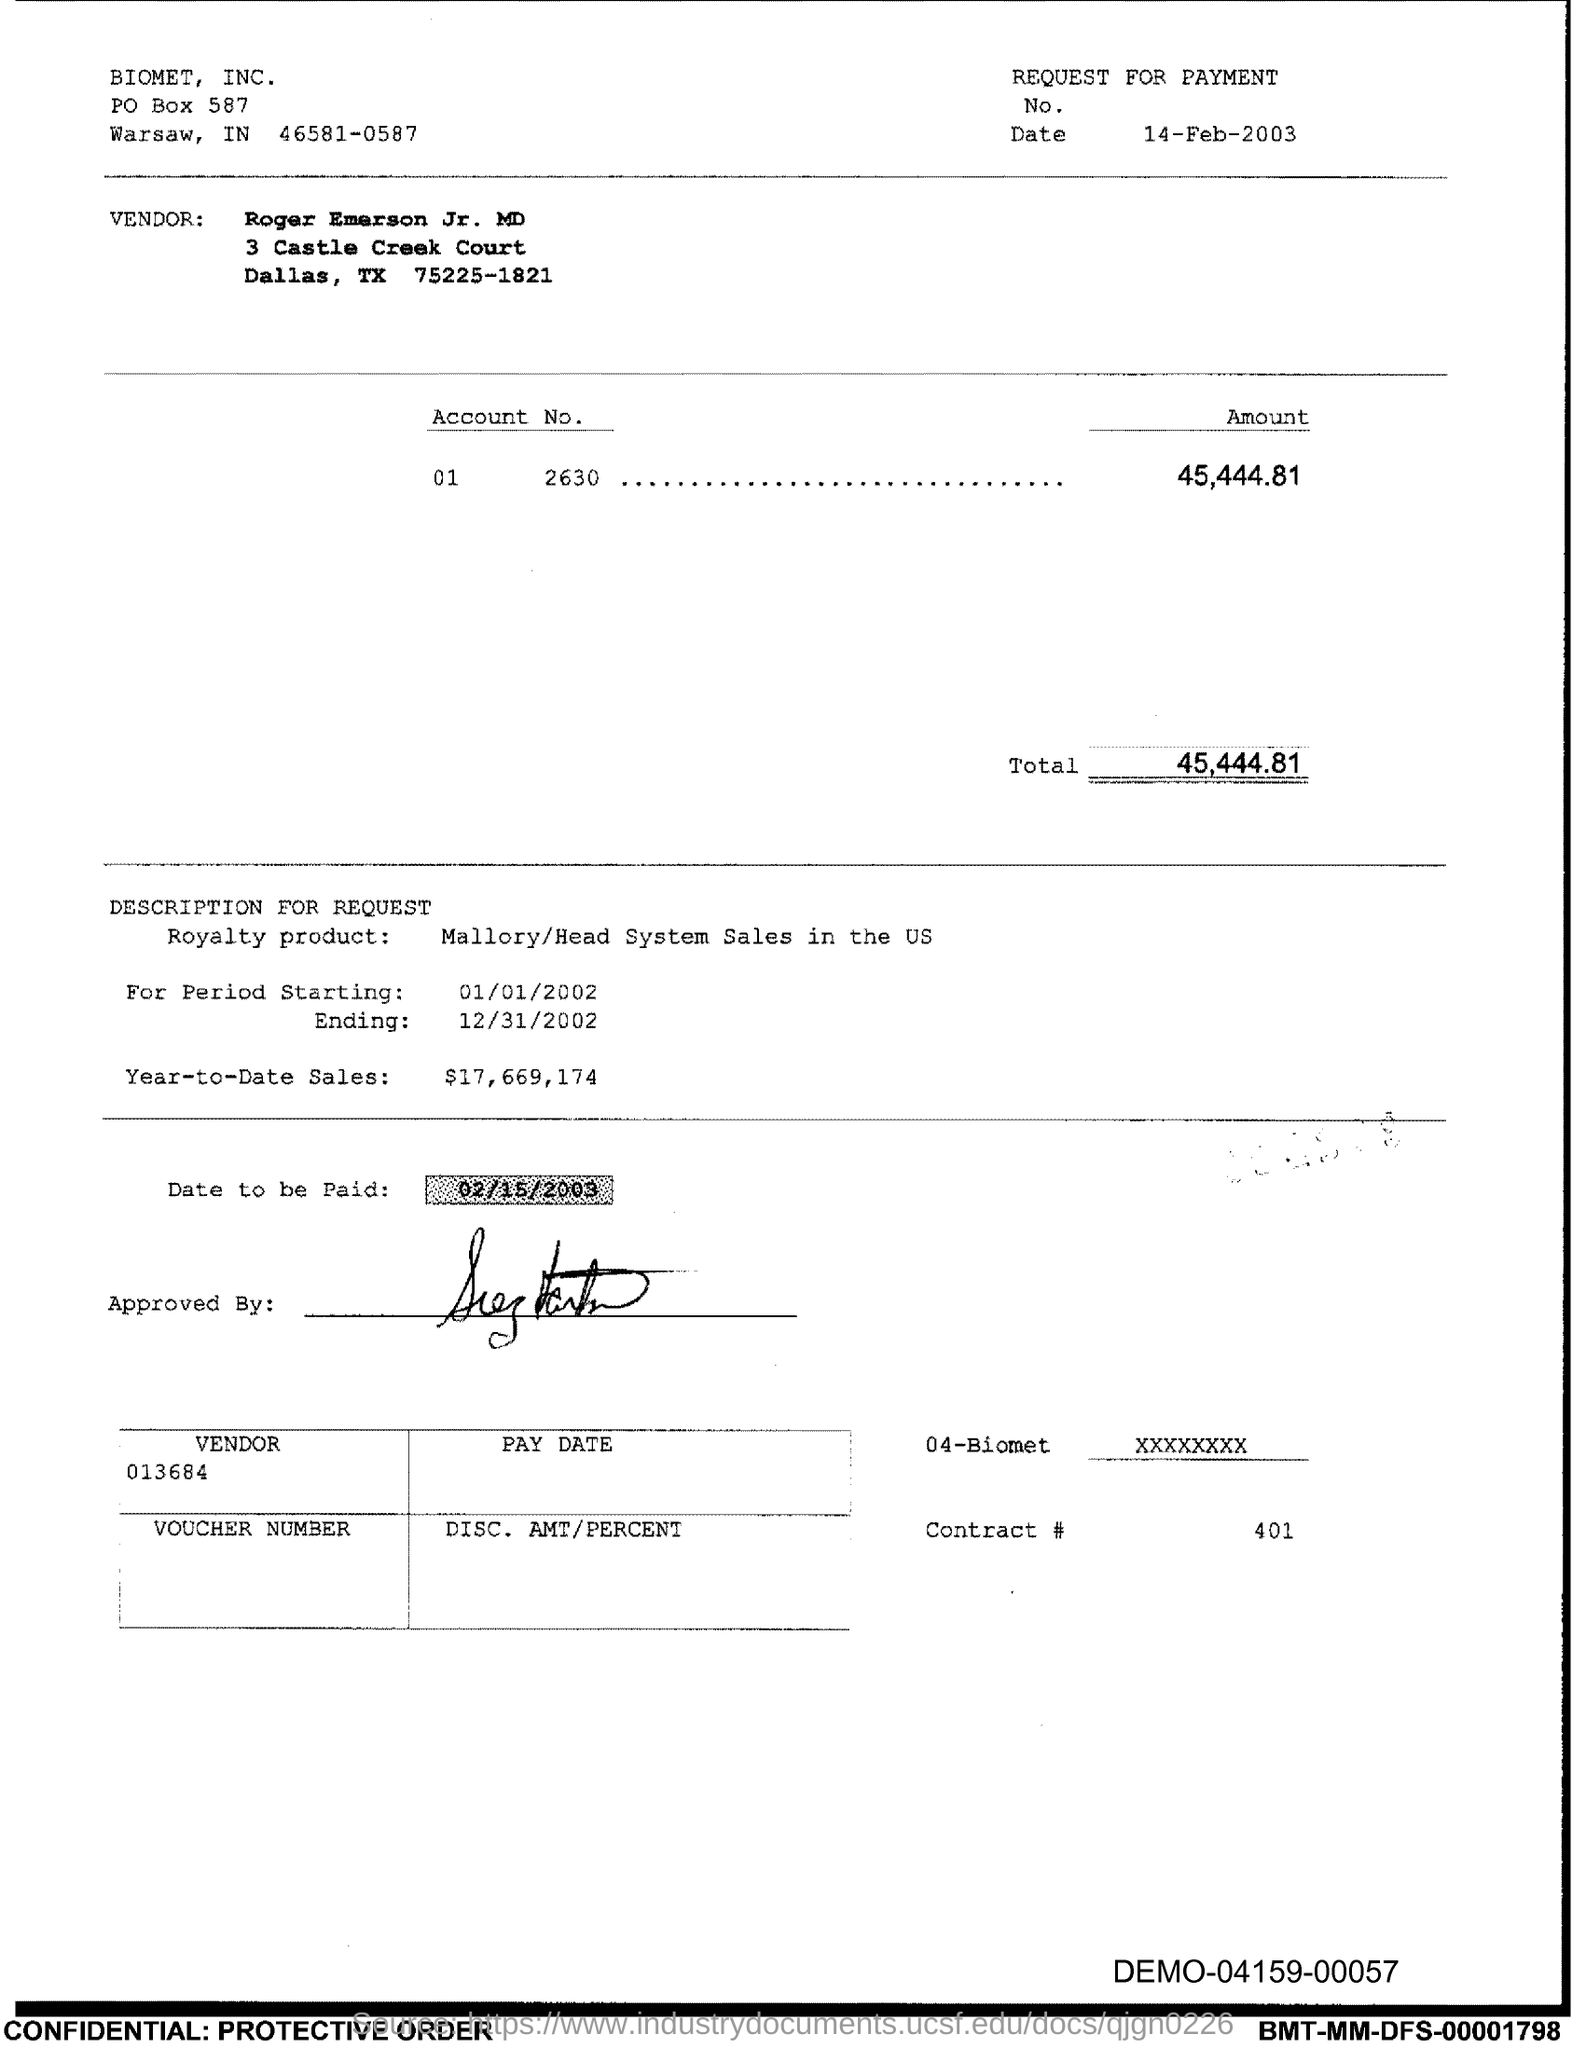What is the total amount requested for payment? The total amount requested for payment as stated on the document is $45,444.81, which is the figure at the bottom of the 'Amount' column. 